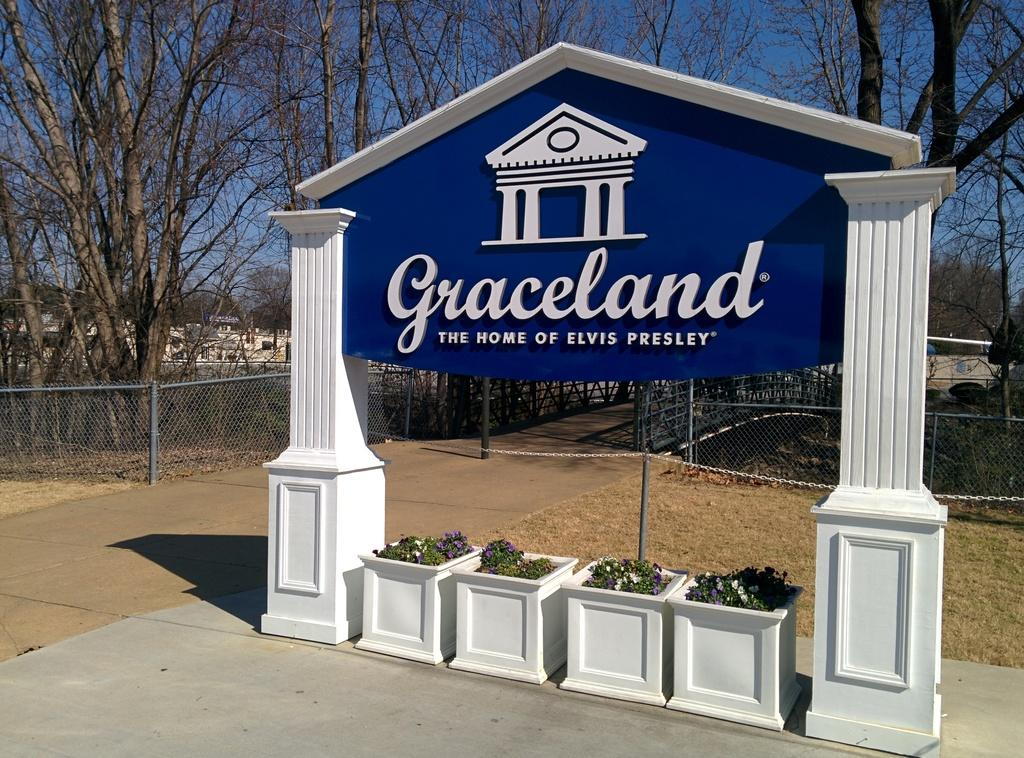What type of objects are in the pots in the image? There are plants and flowers in the pots in the image. Where are the pots located in relation to the arch? The pots are under an arch in the image. What other structures can be seen in the image? There is a pole, a chain, a fence, houses, and a bridge in the image. What type of vegetation is visible in the image? There are trees in the image. What is visible in the sky in the image? The sky is visible in the image. What type of cabbage is being kicked under the bridge in the image? There is no cabbage or kicking activity present in the image. Can you locate the map that shows the route to the nearest park in the image? There is no map present in the image. 